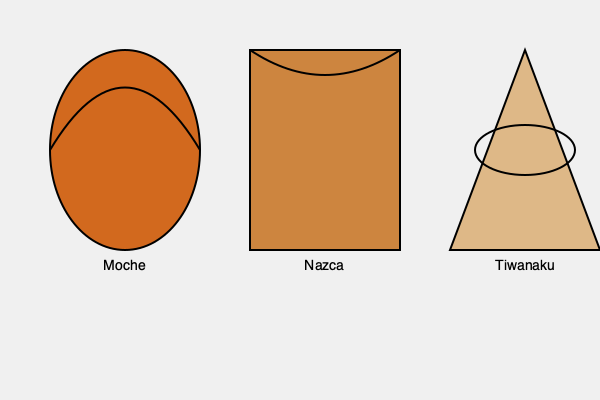Based on the illustrated pottery styles from three pre-Columbian cultures, which culture's pottery design is most likely to have been influenced by their coastal environment and marine resources? To answer this question, we need to analyze the characteristics of each pottery style and consider their potential environmental influences:

1. Moche pottery:
   - Rounded, bulbous shape
   - Curved, wave-like top
   - These features resemble ocean waves and marine life forms

2. Nazca pottery:
   - Rectangular shape
   - Straight lines and angles
   - No obvious marine-inspired features

3. Tiwanaku pottery:
   - Triangular shape
   - Geometric patterns
   - No clear coastal or marine influences

The Moche pottery shows the strongest connection to a coastal environment:
- The rounded shape could represent the smooth, worn shapes of beach pebbles or shells
- The curved top resembles ocean waves
- These design elements suggest a culture deeply connected to the sea

In contrast, the Nazca and Tiwanaku pottery styles feature more geometric shapes and straight lines, which don't immediately evoke coastal imagery.

Historically, the Moche civilization was indeed located on the north coast of Peru, with their economy and culture heavily influenced by marine resources. This aligns with the marine-inspired elements in their pottery design.
Answer: Moche 